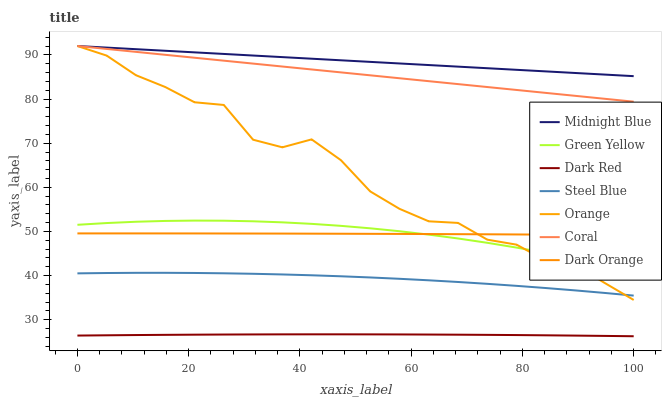Does Dark Red have the minimum area under the curve?
Answer yes or no. Yes. Does Midnight Blue have the maximum area under the curve?
Answer yes or no. Yes. Does Midnight Blue have the minimum area under the curve?
Answer yes or no. No. Does Dark Red have the maximum area under the curve?
Answer yes or no. No. Is Coral the smoothest?
Answer yes or no. Yes. Is Orange the roughest?
Answer yes or no. Yes. Is Midnight Blue the smoothest?
Answer yes or no. No. Is Midnight Blue the roughest?
Answer yes or no. No. Does Dark Red have the lowest value?
Answer yes or no. Yes. Does Midnight Blue have the lowest value?
Answer yes or no. No. Does Orange have the highest value?
Answer yes or no. Yes. Does Dark Red have the highest value?
Answer yes or no. No. Is Steel Blue less than Coral?
Answer yes or no. Yes. Is Midnight Blue greater than Steel Blue?
Answer yes or no. Yes. Does Dark Orange intersect Orange?
Answer yes or no. Yes. Is Dark Orange less than Orange?
Answer yes or no. No. Is Dark Orange greater than Orange?
Answer yes or no. No. Does Steel Blue intersect Coral?
Answer yes or no. No. 